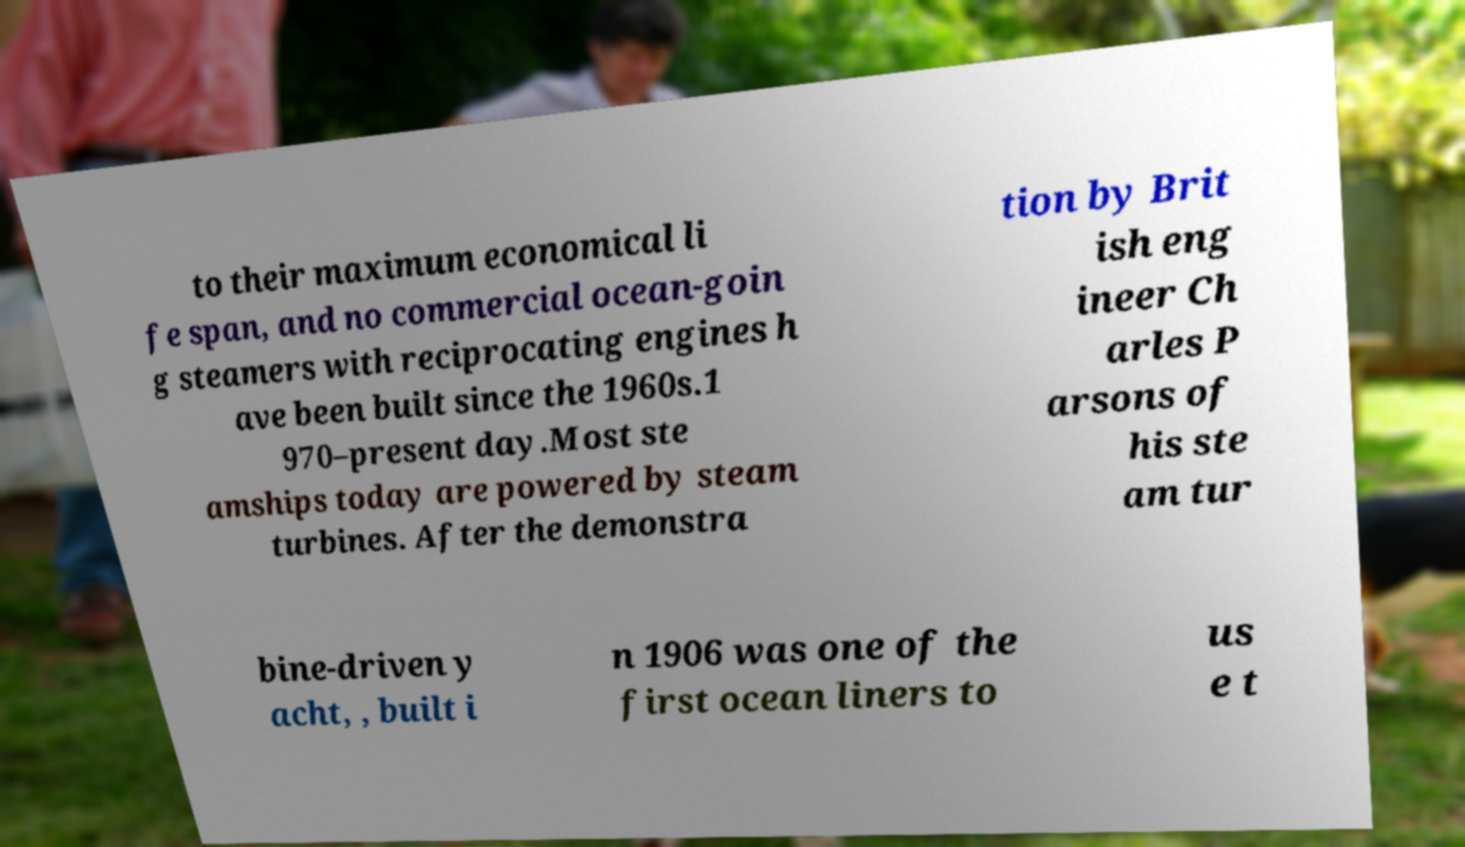I need the written content from this picture converted into text. Can you do that? to their maximum economical li fe span, and no commercial ocean-goin g steamers with reciprocating engines h ave been built since the 1960s.1 970–present day.Most ste amships today are powered by steam turbines. After the demonstra tion by Brit ish eng ineer Ch arles P arsons of his ste am tur bine-driven y acht, , built i n 1906 was one of the first ocean liners to us e t 